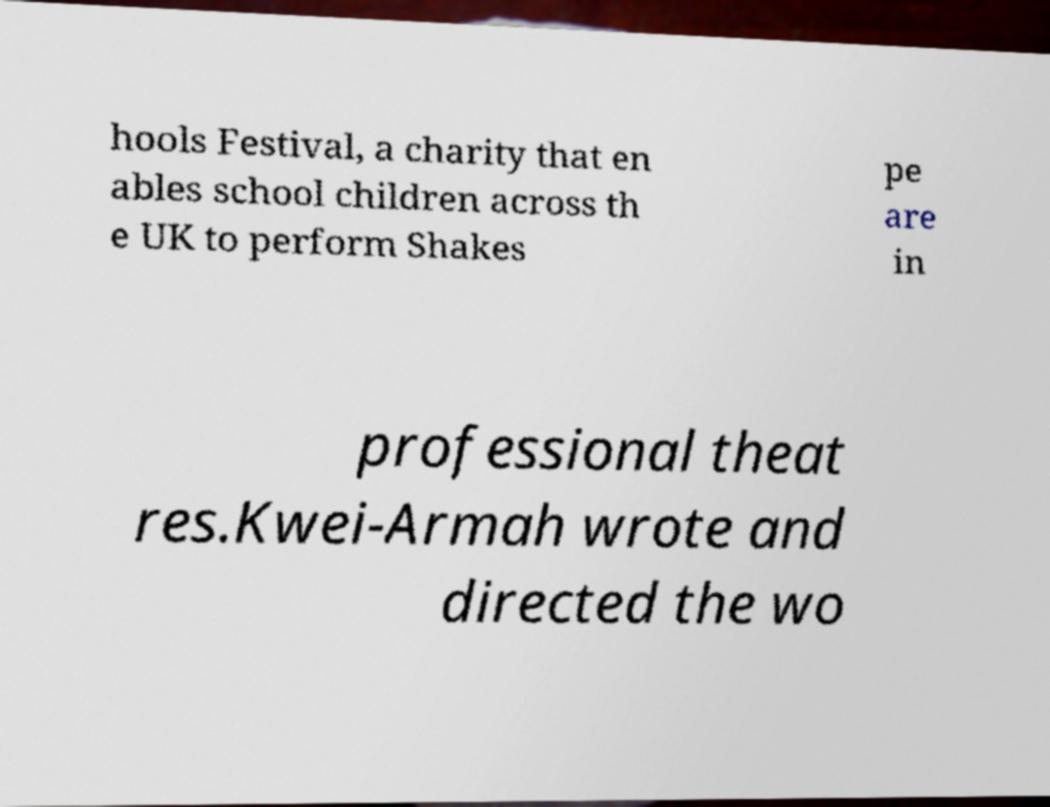I need the written content from this picture converted into text. Can you do that? hools Festival, a charity that en ables school children across th e UK to perform Shakes pe are in professional theat res.Kwei-Armah wrote and directed the wo 